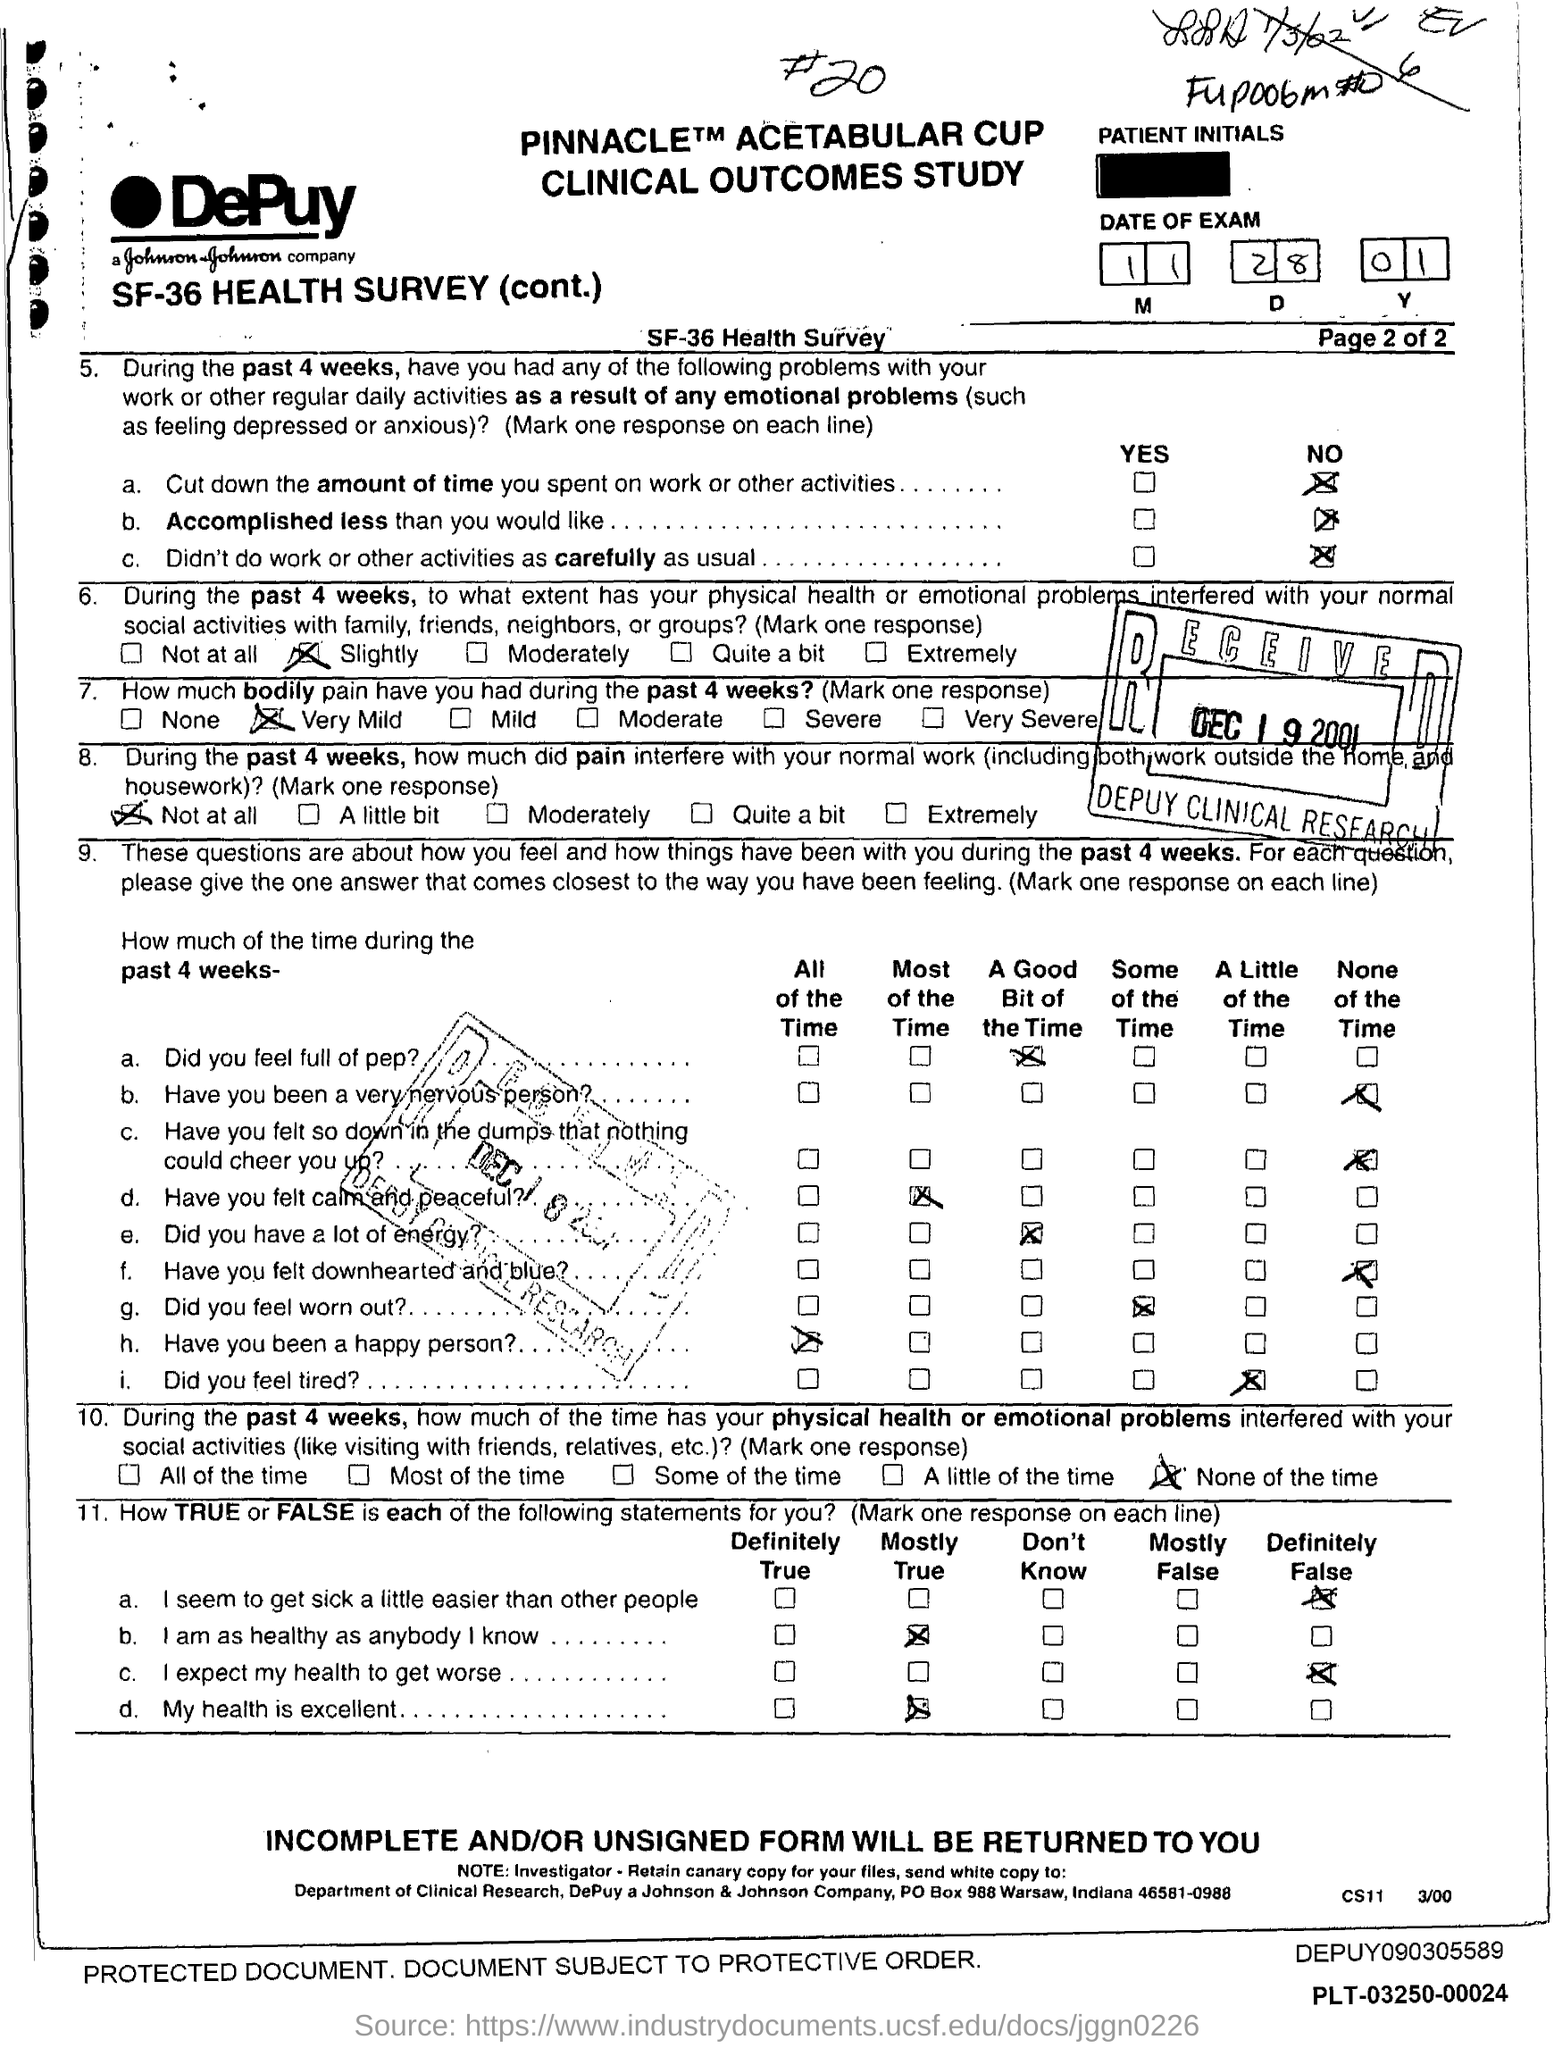List a handful of essential elements in this visual. During the past 4 weeks, I have experienced very mild bodily pain as per the health survey. The date of the exam specified in the form is November 28, 2001. 